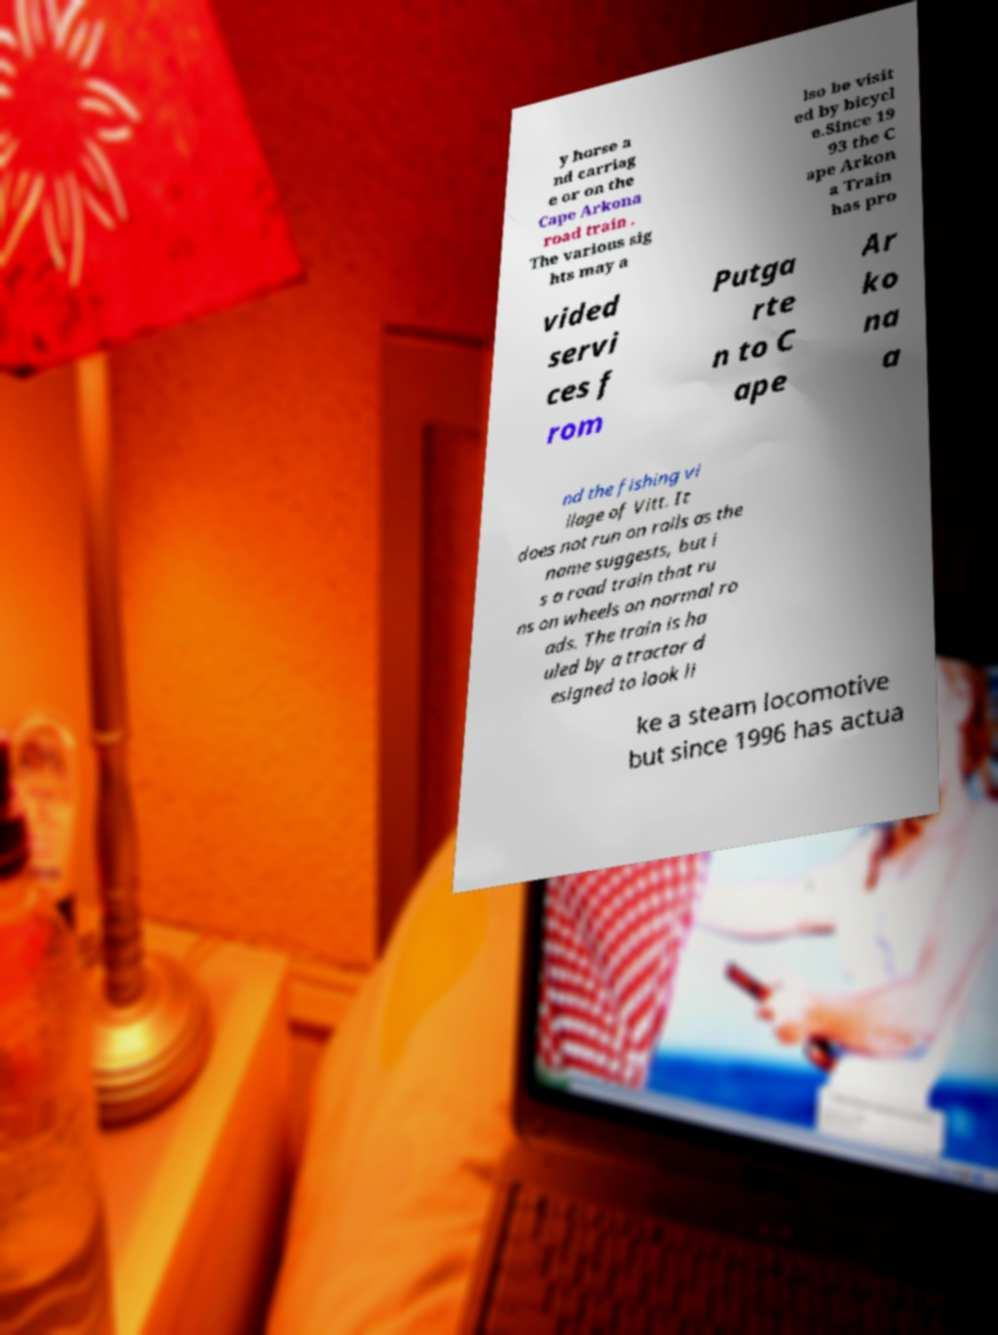Please identify and transcribe the text found in this image. y horse a nd carriag e or on the Cape Arkona road train . The various sig hts may a lso be visit ed by bicycl e.Since 19 93 the C ape Arkon a Train has pro vided servi ces f rom Putga rte n to C ape Ar ko na a nd the fishing vi llage of Vitt. It does not run on rails as the name suggests, but i s a road train that ru ns on wheels on normal ro ads. The train is ha uled by a tractor d esigned to look li ke a steam locomotive but since 1996 has actua 